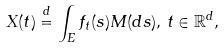<formula> <loc_0><loc_0><loc_500><loc_500>X ( t ) \stackrel { d } { = } \int _ { E } f _ { t } ( s ) M ( d s ) , \, t \in \mathbb { R } ^ { d } ,</formula> 